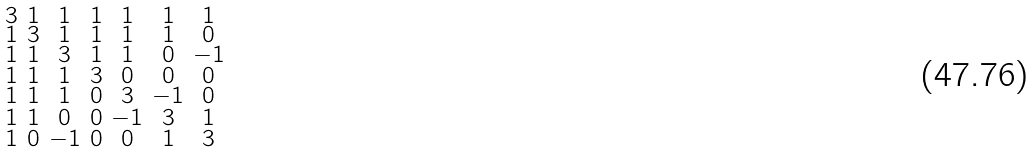<formula> <loc_0><loc_0><loc_500><loc_500>\begin{smallmatrix} 3 & 1 & 1 & 1 & 1 & 1 & 1 \\ 1 & 3 & 1 & 1 & 1 & 1 & 0 \\ 1 & 1 & 3 & 1 & 1 & 0 & - 1 \\ 1 & 1 & 1 & 3 & 0 & 0 & 0 \\ 1 & 1 & 1 & 0 & 3 & - 1 & 0 \\ 1 & 1 & 0 & 0 & - 1 & 3 & 1 \\ 1 & 0 & - 1 & 0 & 0 & 1 & 3 \end{smallmatrix}</formula> 